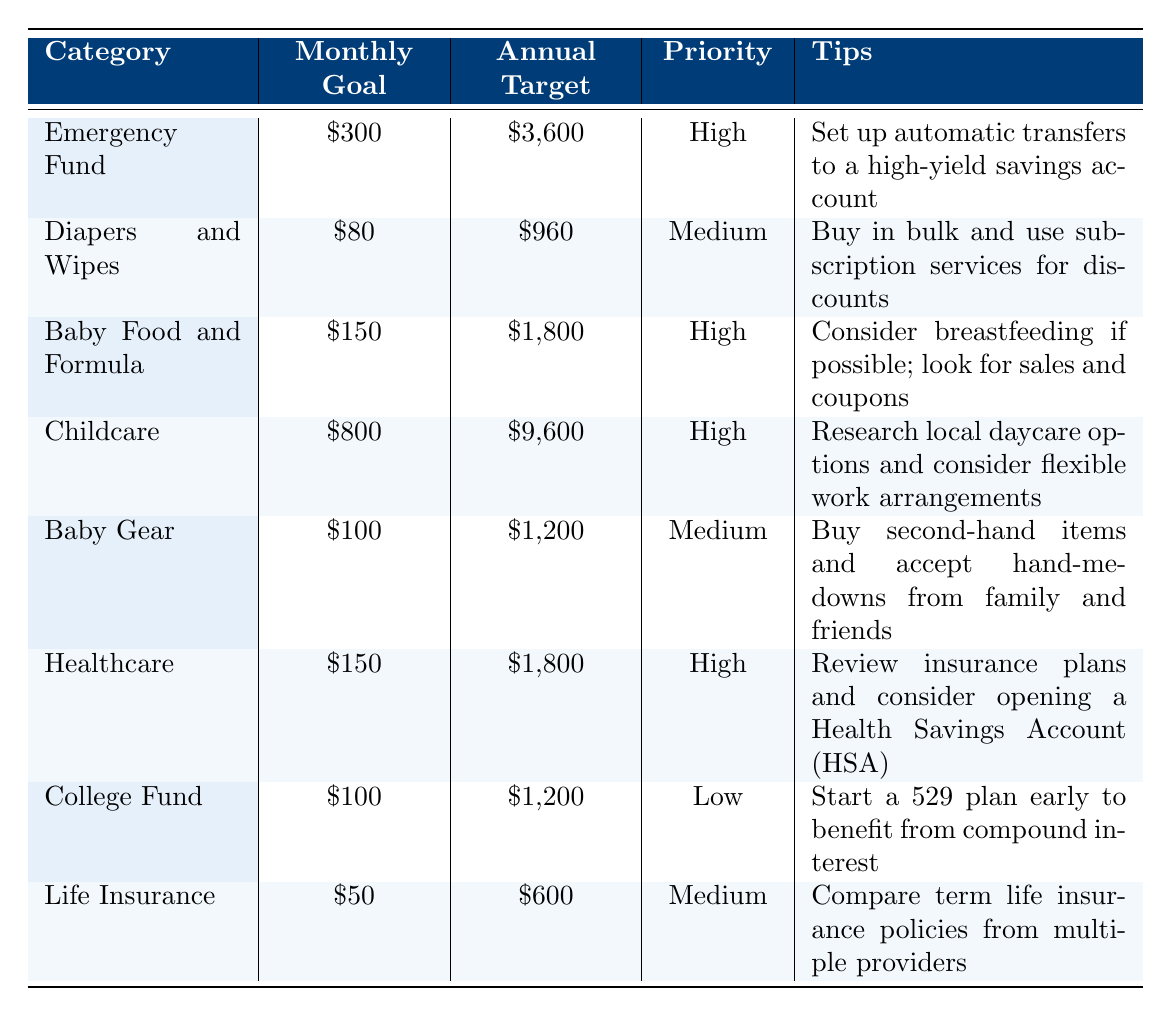What is the monthly goal for the Emergency Fund category? The table states that the monthly goal for the Emergency Fund category is directly listed as $300.
Answer: $300 What is the annual target for Baby Food and Formula? According to the table, the annual target for Baby Food and Formula is written as $1,800.
Answer: $1,800 How much should new parents save monthly for Childcare? The table lists the monthly savings goal for Childcare as $800.
Answer: $800 Which category has the highest annual target? By comparing the annual targets listed, Childcare has the highest annual target at $9,600.
Answer: Childcare Is the priority level for Healthcare High? The priority level for the Healthcare category is noted as High in the table, indicating that it is indeed a High priority.
Answer: Yes What is the total monthly goal for Diapers and Wipes and Baby Gear combined? To find this total, add the monthly goals for both categories: $80 (Diapers and Wipes) + $100 (Baby Gear) = $180.
Answer: $180 What is the difference between the annual target for College Fund and Life Insurance? The annual target for College Fund is $1,200 and for Life Insurance, it is $600. The difference is $1,200 - $600 = $600.
Answer: $600 What is the average monthly goal across all the categories listed? First, sum all monthly goals: $300 + $80 + $150 + $800 + $100 + $150 + $100 + $50 = $1,730. Then, divide by the number of categories (8): $1,730 / 8 = $216.25.
Answer: $216.25 Which tips are recommended for saving on Baby Food and Formula and Diapers and Wipes? The tips from the table are: for Baby Food and Formula, it is recommended to consider breastfeeding if possible and to look for sales and coupons; for Diapers and Wipes, it suggests buying in bulk and using subscription services for discounts.
Answer: Tips mentioned above What is the total amount new parents should target for an Emergency Fund in the first year? The table shows that the annual target for an Emergency Fund is $3,600, indicating that is the total amount new parents should save in their first year.
Answer: $3,600 